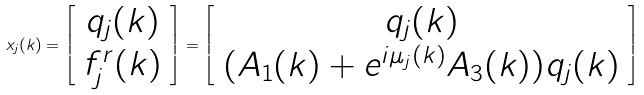Convert formula to latex. <formula><loc_0><loc_0><loc_500><loc_500>x _ { j } ( k ) = \left [ \begin{array} { c } q _ { j } ( k ) \\ f _ { j } ^ { r } ( k ) \end{array} \right ] = \left [ \begin{array} { c } q _ { j } ( k ) \\ ( A _ { 1 } ( k ) + e ^ { i \mu _ { j } ( k ) } A _ { 3 } ( k ) ) q _ { j } ( k ) \end{array} \right ]</formula> 